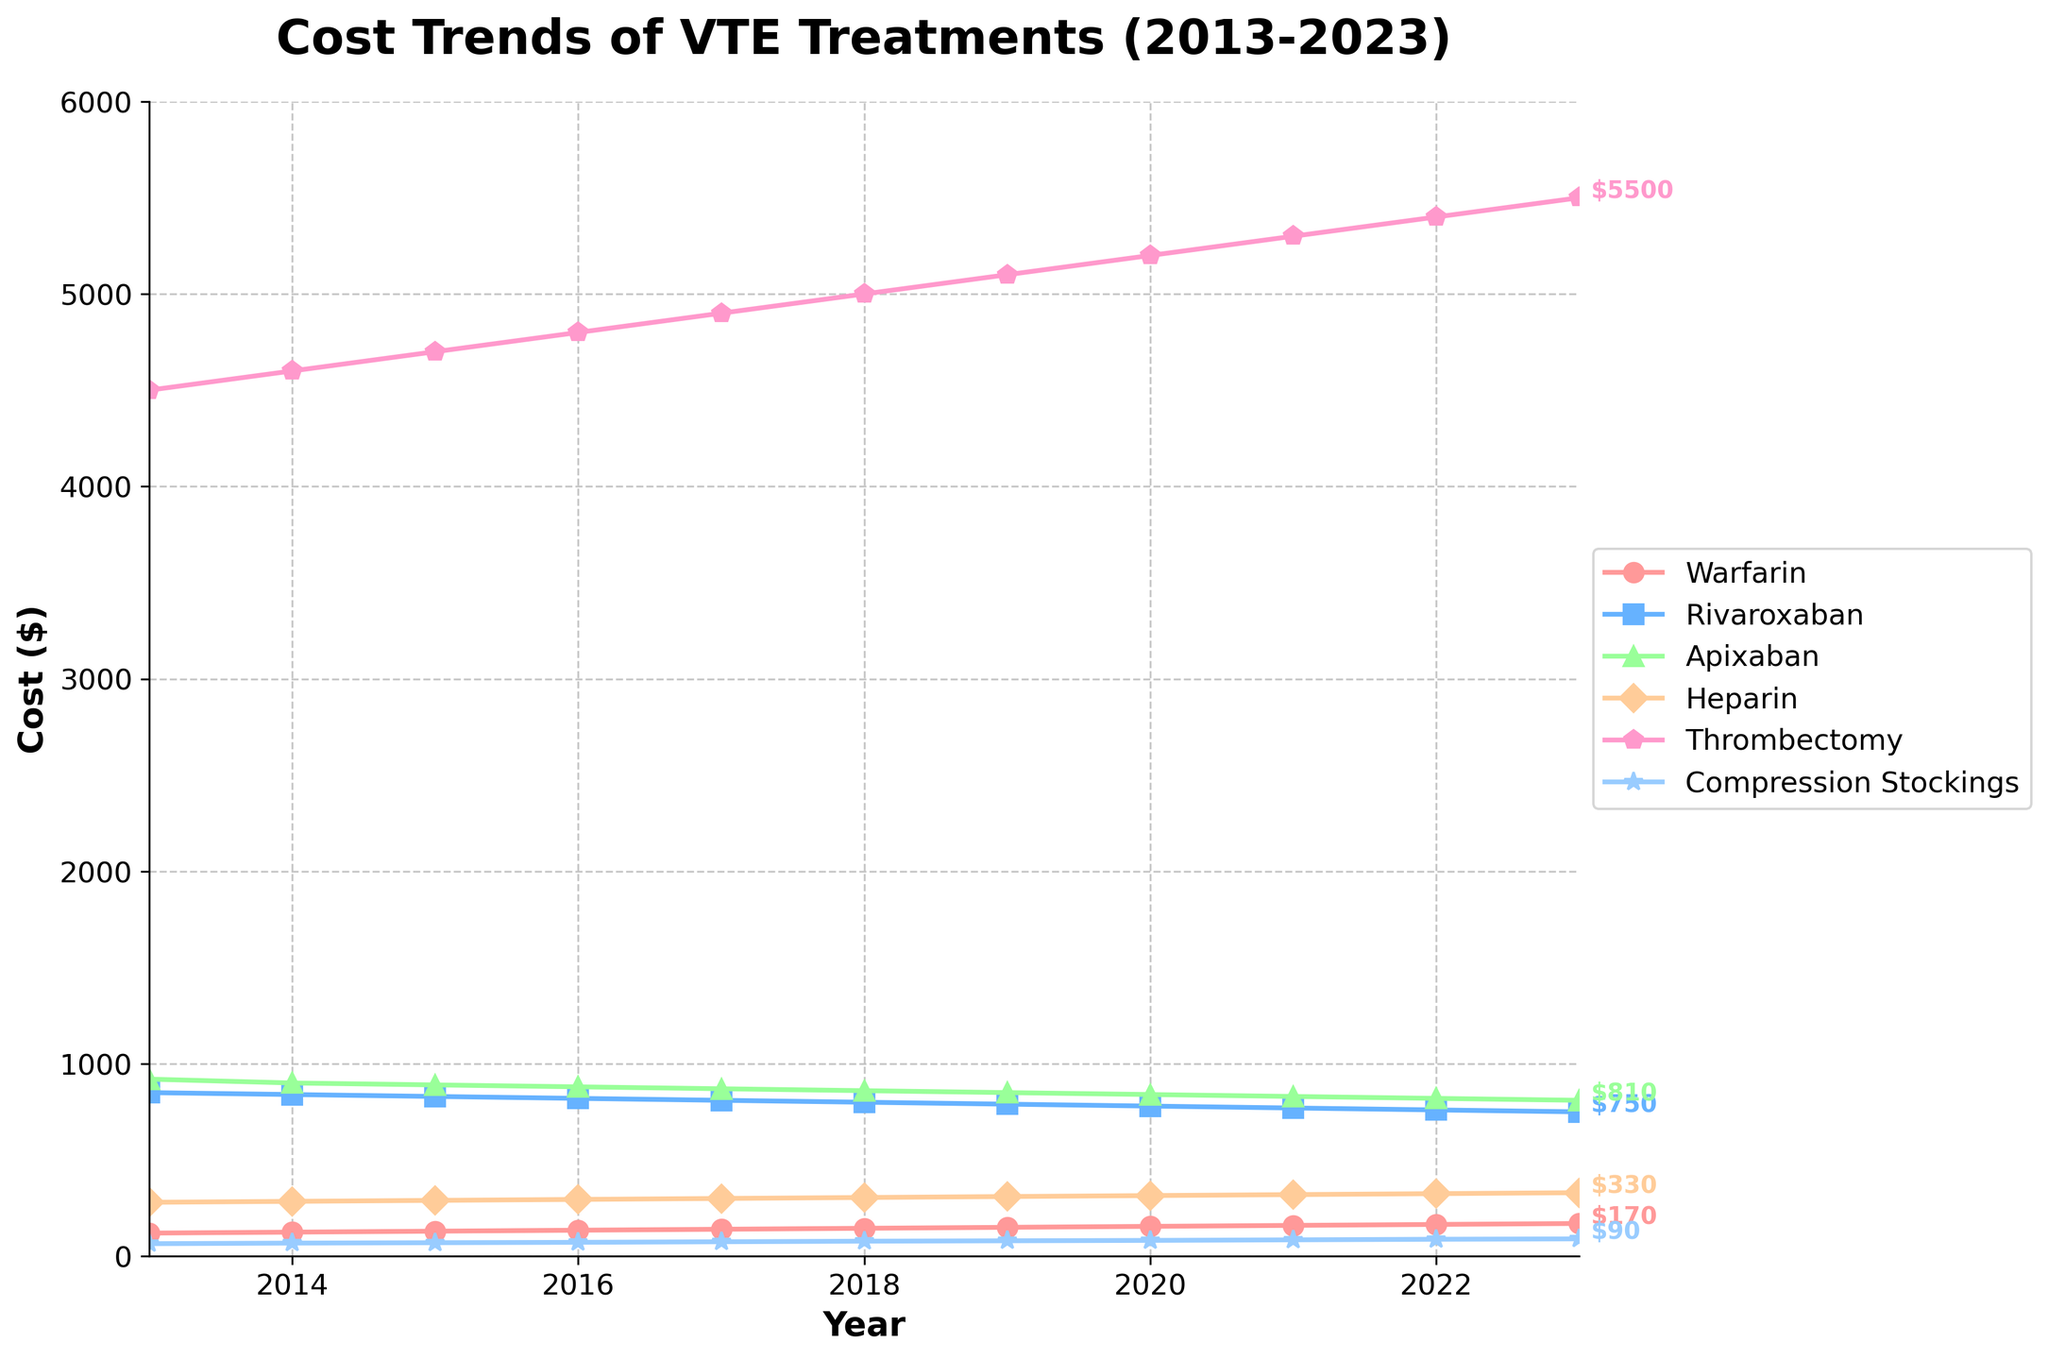What year did compression stockings become the least expensive treatment? Observe the trend line for compression stockings, denoted with the least height, and check the years. Compression stockings are consistently the least expensive from 2013 to 2023.
Answer: 2013 How much did the cost of Rivaroxaban decrease from 2013 to 2023? Locate the cost of Rivaroxaban in 2013 ($850) and compare it to 2023 ($750). Compute the difference: 850 - 750.
Answer: $100 Which treatment showed the highest cost in 2023? Compare the last points of all the treatment lines in 2023. Thrombectomy has the highest value at $5500.
Answer: Thrombectomy Between which two consecutive years did Apixaban experience the most significant cost drop? By visually comparing the slope (downward trend) of the Apixaban line between consecutive years, 2013 to 2014 shows the steepest drop, from $920 to $900.
Answer: 2013-2014 How much did the cost of Heparin increase on average each year from 2013 to 2023? Calculate the difference in cost of Heparin between 2013 ($280) and 2023 ($330), which is $330 - $280 = $50. Then divide this by the number of years (2023-2013 = 10 years), so $50/10 = $5 per year.
Answer: $5 Which treatment had the smallest increase in cost over the decade? Compare the cost differences over the decade for each treatment. Apixaban increased from $920 to $810, a total decrease of $110, but since this is an increase comparison, we see Compression Stockings increased the least from $65 to $90 ($25 increase).
Answer: Compression Stockings In what year did the cost of Warfarin reach $150? Follow the Warfarin trend line to identify when it first reaches (or exceeds) $150. It reaches $150 in 2019.
Answer: 2019 Which treatments had surpassed $5000 by 2023? Check the trendlines and final values in 2023. Only Thrombectomy passed this mark, with costs reaching $5500.
Answer: Thrombectomy Compare the cost trends of Warfarin and Apixaban. Which one had a steadier trend? Observing the lines, Warfarin steadily increased every year with no fluctuations, whereas Apixaban had a slight downward slope. Thus, Warfarin had a steadier trend.
Answer: Warfarin 